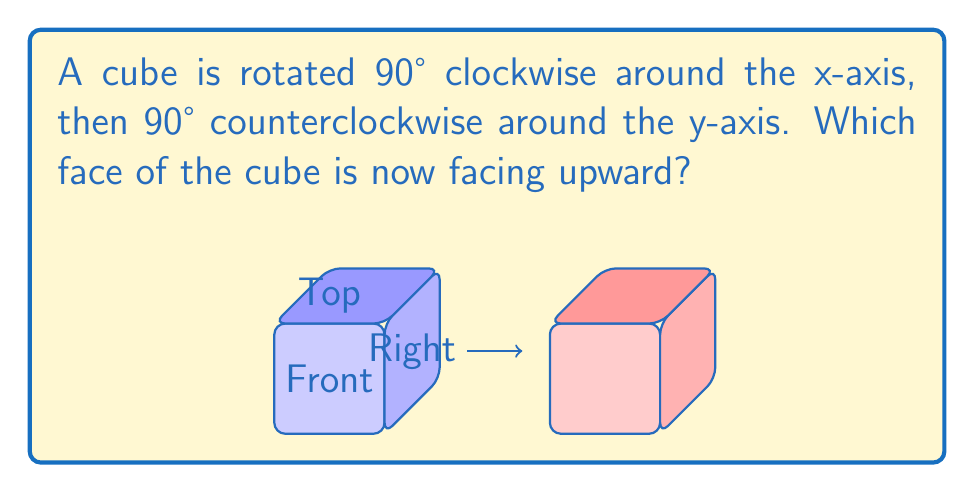Can you solve this math problem? Let's approach this step-by-step:

1) First, let's consider the initial orientation of the cube:
   - The top face is facing up (positive y-axis)
   - The front face is facing towards us (positive z-axis)
   - The right face is facing right (positive x-axis)

2) The first rotation is 90° clockwise around the x-axis:
   - This rotation moves the top face to the back
   - The front face becomes the new top face
   - The bottom face becomes the new front face

3) After this first rotation, the orientation is:
   - The front face is now facing up (positive y-axis)
   - The bottom face is now facing towards us (positive z-axis)
   - The right face is still facing right (positive x-axis)

4) The second rotation is 90° counterclockwise around the y-axis:
   - This rotation moves the right face to the front
   - The front face (which was facing up) moves to the left
   - The left face moves to the back

5) After this second rotation, the final orientation is:
   - The right face is now facing towards us (positive z-axis)
   - The front face (which was facing up after the first rotation) is now facing left (negative x-axis)
   - The top face from the original orientation is still at the back

Therefore, the face that is now facing upward (positive y-axis) is the face that was originally the right face of the cube.
Answer: Right face 